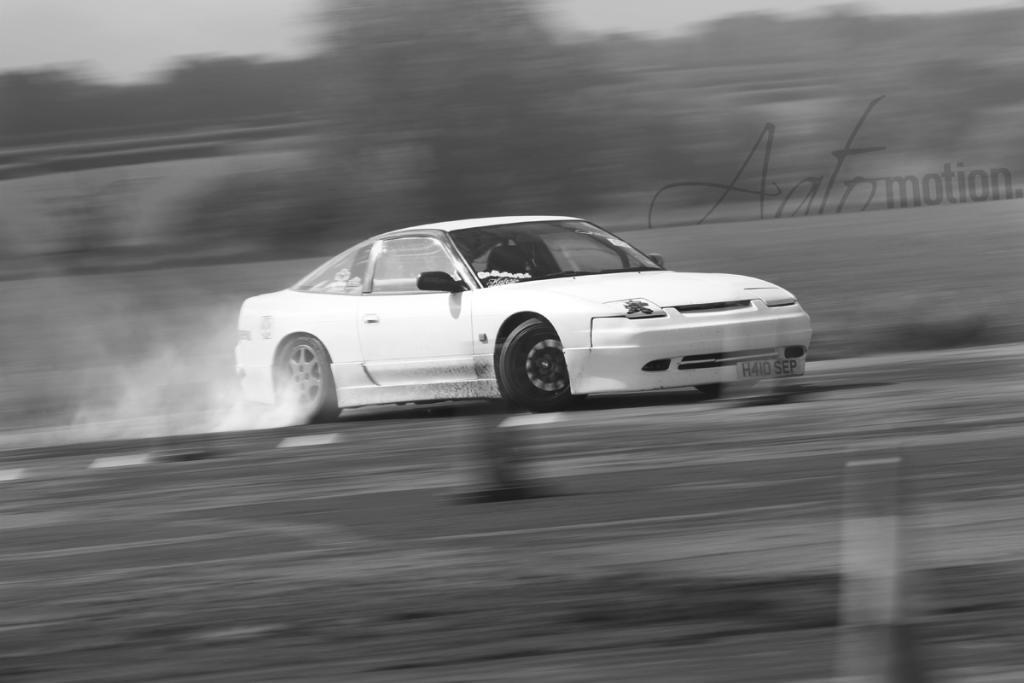What is the main subject in the foreground of the image? There is a car in the foreground of the image. What is the car doing in the image? The car is moving on the road. How is the background of the image depicted? The background of the image is blurred. What can be seen coming from the car's tire? There is smoke visible behind the car's tire. What type of tin can be seen blowing in the wind in the image? There is no tin present in the image, nor is there any wind depicted. 